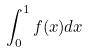<formula> <loc_0><loc_0><loc_500><loc_500>\int _ { 0 } ^ { 1 } f ( x ) d x</formula> 